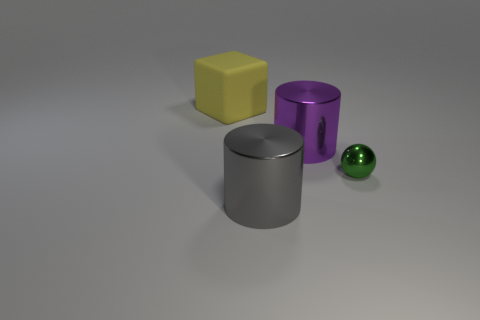Add 3 yellow cubes. How many objects exist? 7 Subtract all blocks. How many objects are left? 3 Add 3 purple metallic cylinders. How many purple metallic cylinders are left? 4 Add 1 big cubes. How many big cubes exist? 2 Subtract 0 brown spheres. How many objects are left? 4 Subtract all big purple cubes. Subtract all yellow things. How many objects are left? 3 